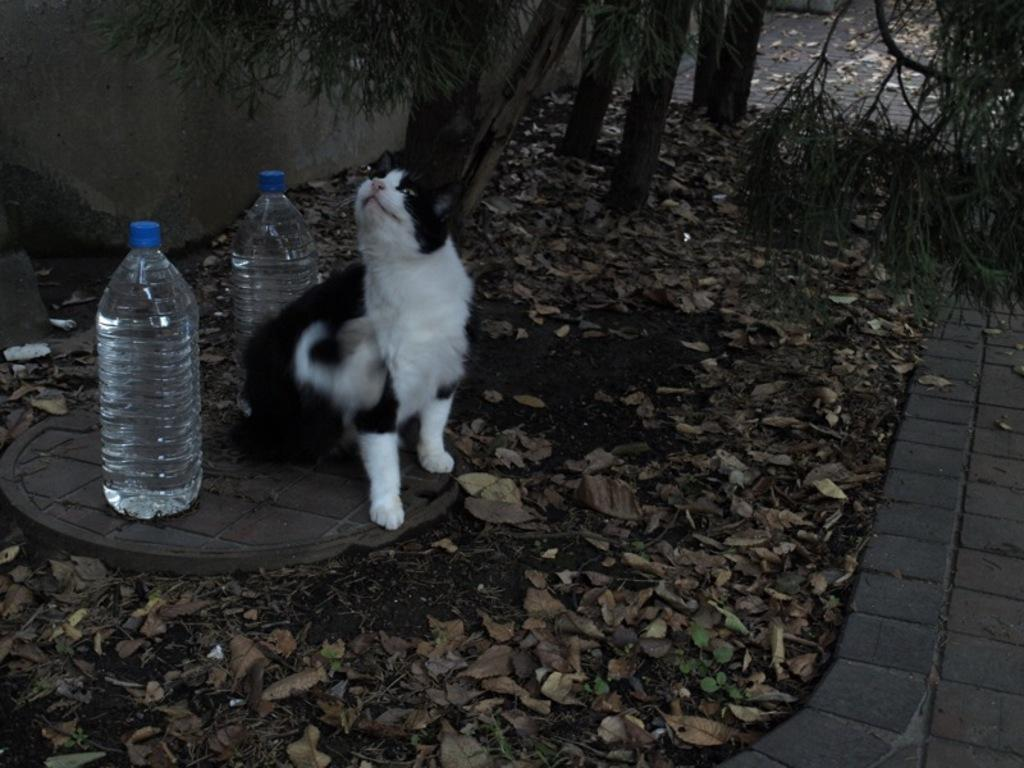What type of animal is in the image? There is a cat in the image. What is the cat doing in the image? The cat is looking at something. What objects can be seen on the left side of the image? There are two water bottles on the left side of the image. How many cakes are on the table in the image? There is no table or cakes present in the image; it features a cat looking at something and two water bottles on the left side. 